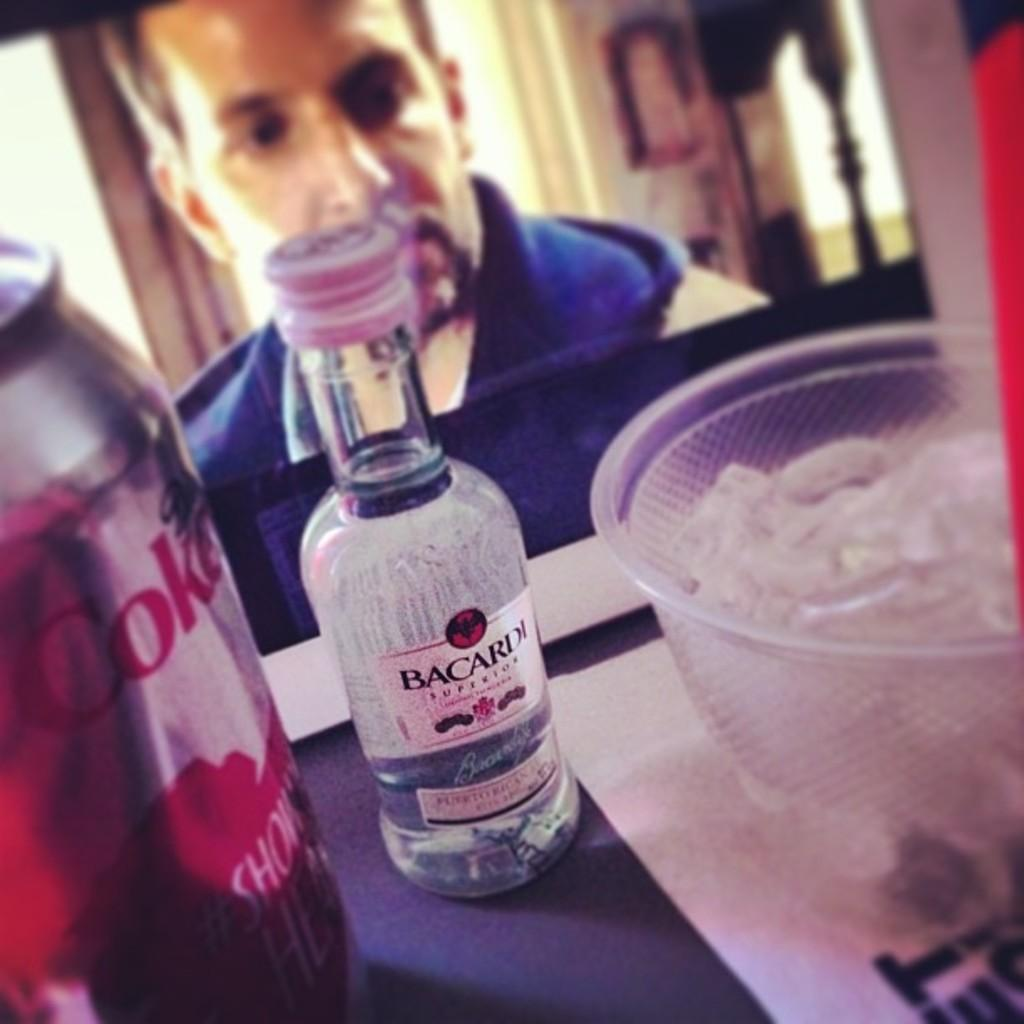What is the main piece of furniture in the image? There is a table in the image. What beverages can be seen on the table? There is a wine bottle and a can of cold drink on the table. What is used to keep the drinks cold in the image? There is a bowl with ice cubes in the image. What type of lumber is being used to construct the table in the image? There is no information about the type of lumber used to construct the table in the image. 